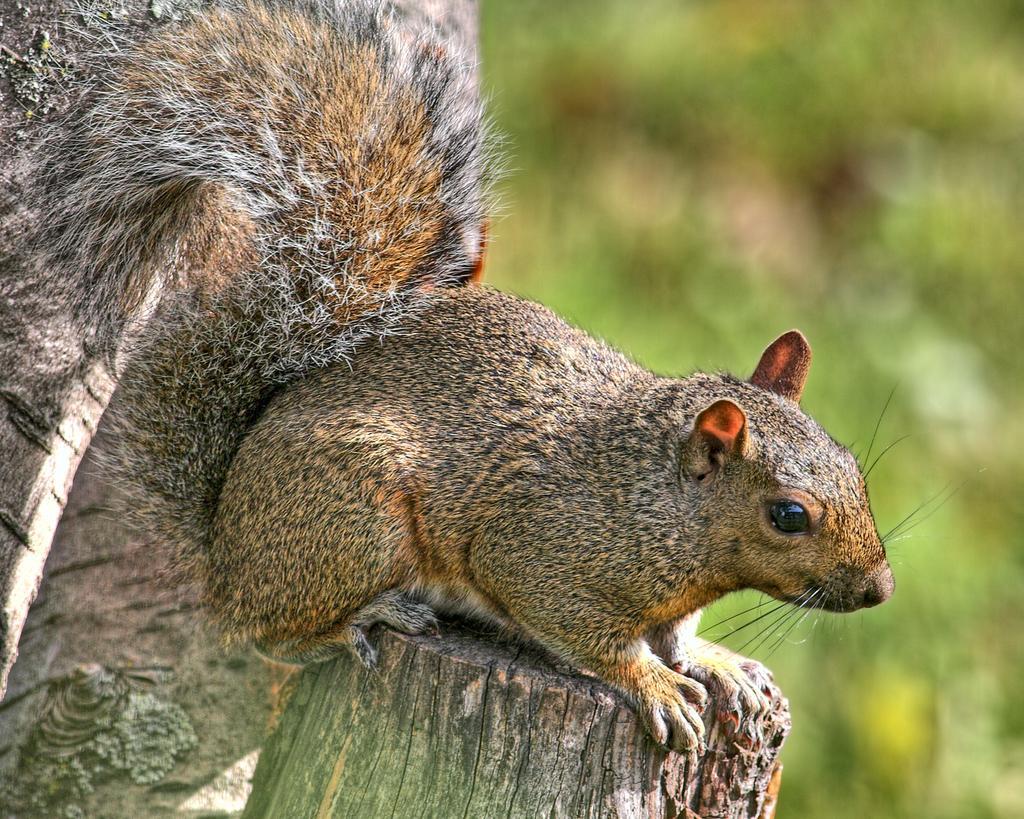Describe this image in one or two sentences. In the center of the image we can see squirrel on the wood. 